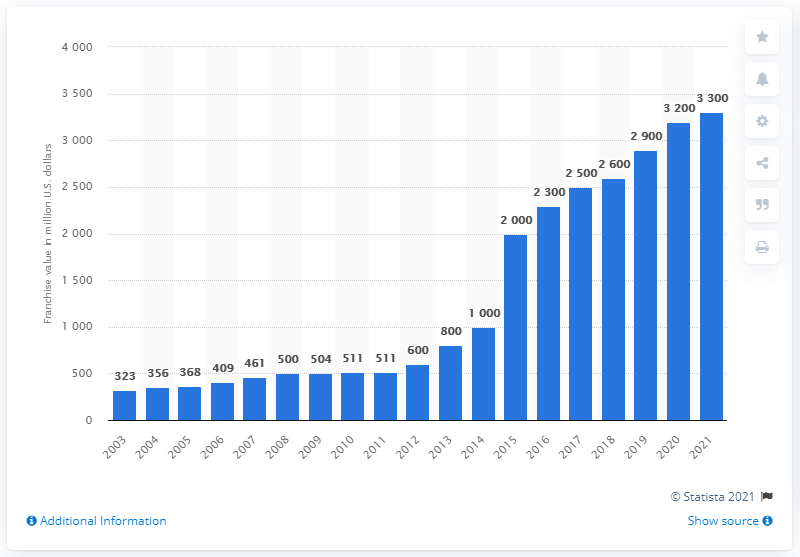What was the estimated value of the Chicago Bulls franchise in 2021? In 2021, the Chicago Bulls were estimated to have a franchise value of approximately $3.3 billion, according to the data shown in the provided chart. 